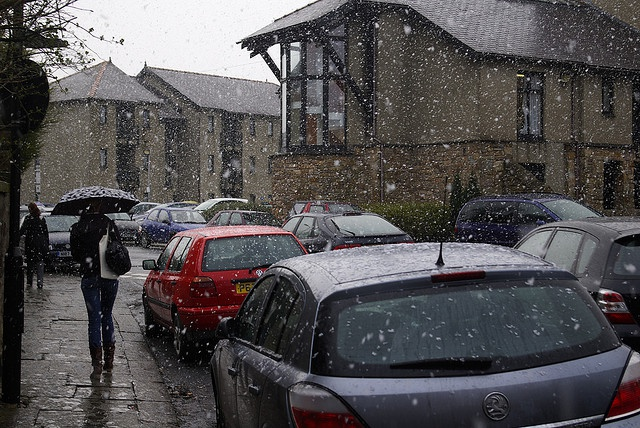Describe the objects in this image and their specific colors. I can see car in black, gray, darkblue, and darkgray tones, car in black, gray, maroon, and lightpink tones, car in black, gray, and darkgray tones, people in black and gray tones, and car in black and gray tones in this image. 